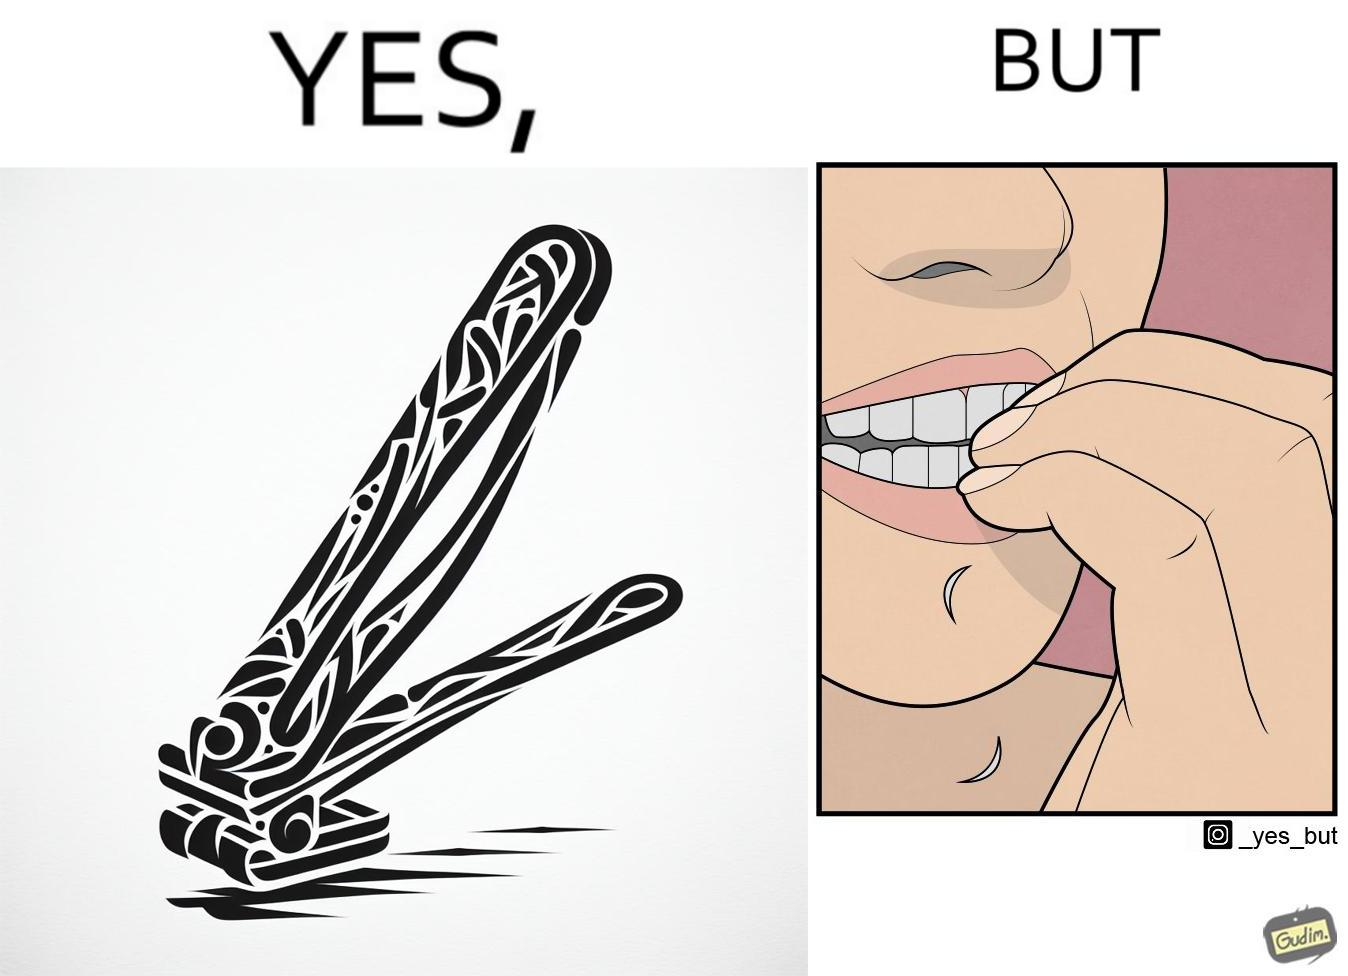Describe the satirical element in this image. The image is ironic, because even after nail clippers are available people prefer biting their nails by teeth 